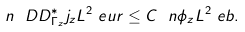Convert formula to latex. <formula><loc_0><loc_0><loc_500><loc_500>\ n { \ D D _ { \Gamma _ { z } } ^ { * } j _ { z } } { L ^ { 2 } _ { \ } e u r } \leq C \ n { \phi _ { z } } { L ^ { 2 } _ { \ } e b } .</formula> 